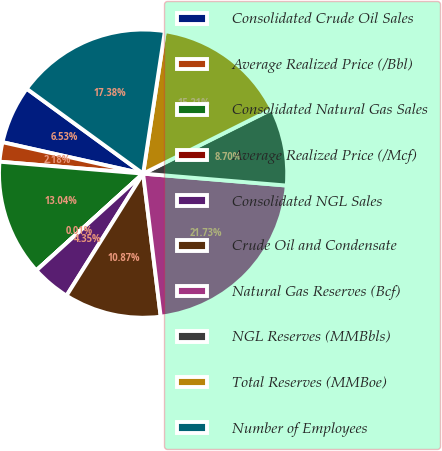Convert chart to OTSL. <chart><loc_0><loc_0><loc_500><loc_500><pie_chart><fcel>Consolidated Crude Oil Sales<fcel>Average Realized Price (/Bbl)<fcel>Consolidated Natural Gas Sales<fcel>Average Realized Price (/Mcf)<fcel>Consolidated NGL Sales<fcel>Crude Oil and Condensate<fcel>Natural Gas Reserves (Bcf)<fcel>NGL Reserves (MMBbls)<fcel>Total Reserves (MMBoe)<fcel>Number of Employees<nl><fcel>6.53%<fcel>2.18%<fcel>13.04%<fcel>0.01%<fcel>4.35%<fcel>10.87%<fcel>21.73%<fcel>8.7%<fcel>15.21%<fcel>17.38%<nl></chart> 